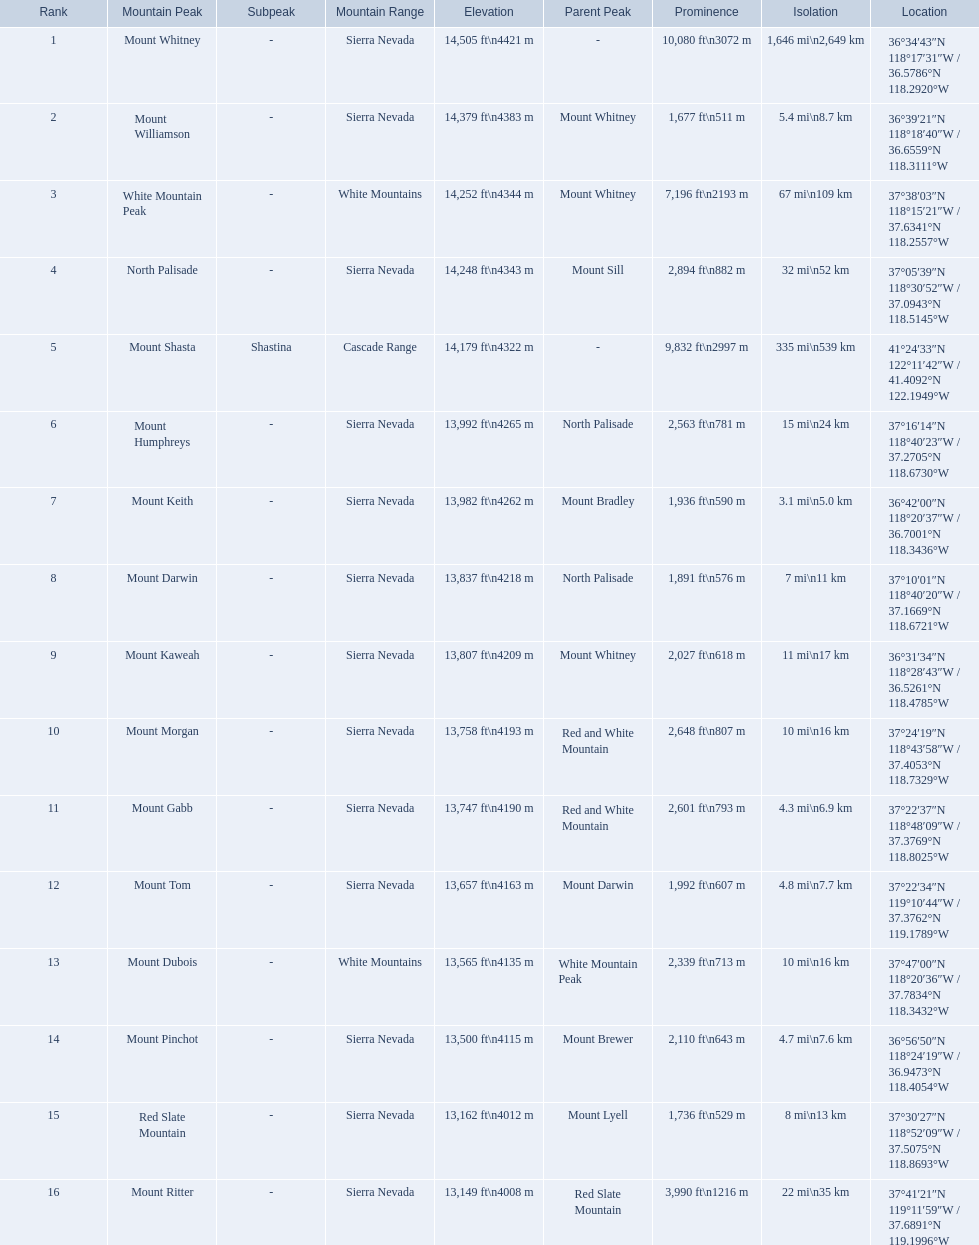Which mountain peak is in the white mountains range? White Mountain Peak. Which mountain is in the sierra nevada range? Mount Whitney. Which mountain is the only one in the cascade range? Mount Shasta. Which mountain peaks have a prominence over 9,000 ft? Mount Whitney, Mount Shasta. Of those, which one has the the highest prominence? Mount Whitney. Help me parse the entirety of this table. {'header': ['Rank', 'Mountain Peak', 'Subpeak', 'Mountain Range', 'Elevation', 'Parent Peak', 'Prominence', 'Isolation', 'Location'], 'rows': [['1', 'Mount Whitney', '-', 'Sierra Nevada', '14,505\xa0ft\\n4421\xa0m', '-', '10,080\xa0ft\\n3072\xa0m', '1,646\xa0mi\\n2,649\xa0km', '36°34′43″N 118°17′31″W\ufeff / \ufeff36.5786°N 118.2920°W'], ['2', 'Mount Williamson', '-', 'Sierra Nevada', '14,379\xa0ft\\n4383\xa0m', 'Mount Whitney', '1,677\xa0ft\\n511\xa0m', '5.4\xa0mi\\n8.7\xa0km', '36°39′21″N 118°18′40″W\ufeff / \ufeff36.6559°N 118.3111°W'], ['3', 'White Mountain Peak', '-', 'White Mountains', '14,252\xa0ft\\n4344\xa0m', 'Mount Whitney', '7,196\xa0ft\\n2193\xa0m', '67\xa0mi\\n109\xa0km', '37°38′03″N 118°15′21″W\ufeff / \ufeff37.6341°N 118.2557°W'], ['4', 'North Palisade', '-', 'Sierra Nevada', '14,248\xa0ft\\n4343\xa0m', 'Mount Sill', '2,894\xa0ft\\n882\xa0m', '32\xa0mi\\n52\xa0km', '37°05′39″N 118°30′52″W\ufeff / \ufeff37.0943°N 118.5145°W'], ['5', 'Mount Shasta', 'Shastina', 'Cascade Range', '14,179\xa0ft\\n4322\xa0m', '-', '9,832\xa0ft\\n2997\xa0m', '335\xa0mi\\n539\xa0km', '41°24′33″N 122°11′42″W\ufeff / \ufeff41.4092°N 122.1949°W'], ['6', 'Mount Humphreys', '-', 'Sierra Nevada', '13,992\xa0ft\\n4265\xa0m', 'North Palisade', '2,563\xa0ft\\n781\xa0m', '15\xa0mi\\n24\xa0km', '37°16′14″N 118°40′23″W\ufeff / \ufeff37.2705°N 118.6730°W'], ['7', 'Mount Keith', '-', 'Sierra Nevada', '13,982\xa0ft\\n4262\xa0m', 'Mount Bradley', '1,936\xa0ft\\n590\xa0m', '3.1\xa0mi\\n5.0\xa0km', '36°42′00″N 118°20′37″W\ufeff / \ufeff36.7001°N 118.3436°W'], ['8', 'Mount Darwin', '-', 'Sierra Nevada', '13,837\xa0ft\\n4218\xa0m', 'North Palisade', '1,891\xa0ft\\n576\xa0m', '7\xa0mi\\n11\xa0km', '37°10′01″N 118°40′20″W\ufeff / \ufeff37.1669°N 118.6721°W'], ['9', 'Mount Kaweah', '-', 'Sierra Nevada', '13,807\xa0ft\\n4209\xa0m', 'Mount Whitney', '2,027\xa0ft\\n618\xa0m', '11\xa0mi\\n17\xa0km', '36°31′34″N 118°28′43″W\ufeff / \ufeff36.5261°N 118.4785°W'], ['10', 'Mount Morgan', '-', 'Sierra Nevada', '13,758\xa0ft\\n4193\xa0m', 'Red and White Mountain', '2,648\xa0ft\\n807\xa0m', '10\xa0mi\\n16\xa0km', '37°24′19″N 118°43′58″W\ufeff / \ufeff37.4053°N 118.7329°W'], ['11', 'Mount Gabb', '-', 'Sierra Nevada', '13,747\xa0ft\\n4190\xa0m', 'Red and White Mountain', '2,601\xa0ft\\n793\xa0m', '4.3\xa0mi\\n6.9\xa0km', '37°22′37″N 118°48′09″W\ufeff / \ufeff37.3769°N 118.8025°W'], ['12', 'Mount Tom', '-', 'Sierra Nevada', '13,657\xa0ft\\n4163\xa0m', 'Mount Darwin', '1,992\xa0ft\\n607\xa0m', '4.8\xa0mi\\n7.7\xa0km', '37°22′34″N 119°10′44″W\ufeff / \ufeff37.3762°N 119.1789°W'], ['13', 'Mount Dubois', '-', 'White Mountains', '13,565\xa0ft\\n4135\xa0m', 'White Mountain Peak', '2,339\xa0ft\\n713\xa0m', '10\xa0mi\\n16\xa0km', '37°47′00″N 118°20′36″W\ufeff / \ufeff37.7834°N 118.3432°W'], ['14', 'Mount Pinchot', '-', 'Sierra Nevada', '13,500\xa0ft\\n4115\xa0m', 'Mount Brewer', '2,110\xa0ft\\n643\xa0m', '4.7\xa0mi\\n7.6\xa0km', '36°56′50″N 118°24′19″W\ufeff / \ufeff36.9473°N 118.4054°W'], ['15', 'Red Slate Mountain', '-', 'Sierra Nevada', '13,162\xa0ft\\n4012\xa0m', 'Mount Lyell', '1,736\xa0ft\\n529\xa0m', '8\xa0mi\\n13\xa0km', '37°30′27″N 118°52′09″W\ufeff / \ufeff37.5075°N 118.8693°W'], ['16', 'Mount Ritter', '-', 'Sierra Nevada', '13,149\xa0ft\\n4008\xa0m', 'Red Slate Mountain', '3,990\xa0ft\\n1216\xa0m', '22\xa0mi\\n35\xa0km', '37°41′21″N 119°11′59″W\ufeff / \ufeff37.6891°N 119.1996°W']]} Which are the highest mountain peaks in california? Mount Whitney, Mount Williamson, White Mountain Peak, North Palisade, Mount Shasta, Mount Humphreys, Mount Keith, Mount Darwin, Mount Kaweah, Mount Morgan, Mount Gabb, Mount Tom, Mount Dubois, Mount Pinchot, Red Slate Mountain, Mount Ritter. Of those, which are not in the sierra nevada range? White Mountain Peak, Mount Shasta, Mount Dubois. Of the mountains not in the sierra nevada range, which is the only mountain in the cascades? Mount Shasta. 